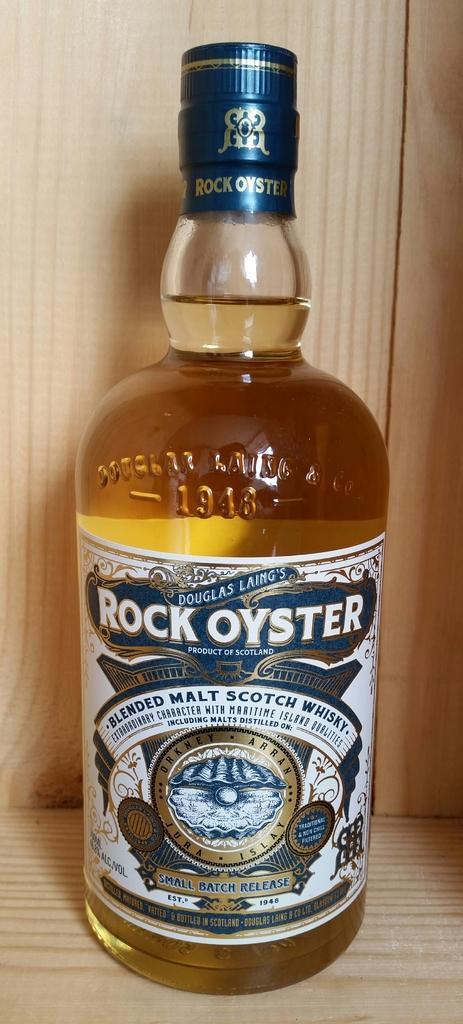Can you describe this image briefly? As we can see in the image there is a bottle on table. 